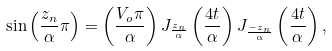Convert formula to latex. <formula><loc_0><loc_0><loc_500><loc_500>\sin \left ( \frac { z _ { n } } { \alpha } \pi \right ) = \left ( \frac { V _ { o } \pi } { \alpha } \right ) J _ { \frac { z _ { n } } { \alpha } } \left ( \frac { 4 t } { \alpha } \right ) J _ { \frac { - z _ { n } } { \alpha } } \left ( \frac { 4 t } { \alpha } \right ) ,</formula> 